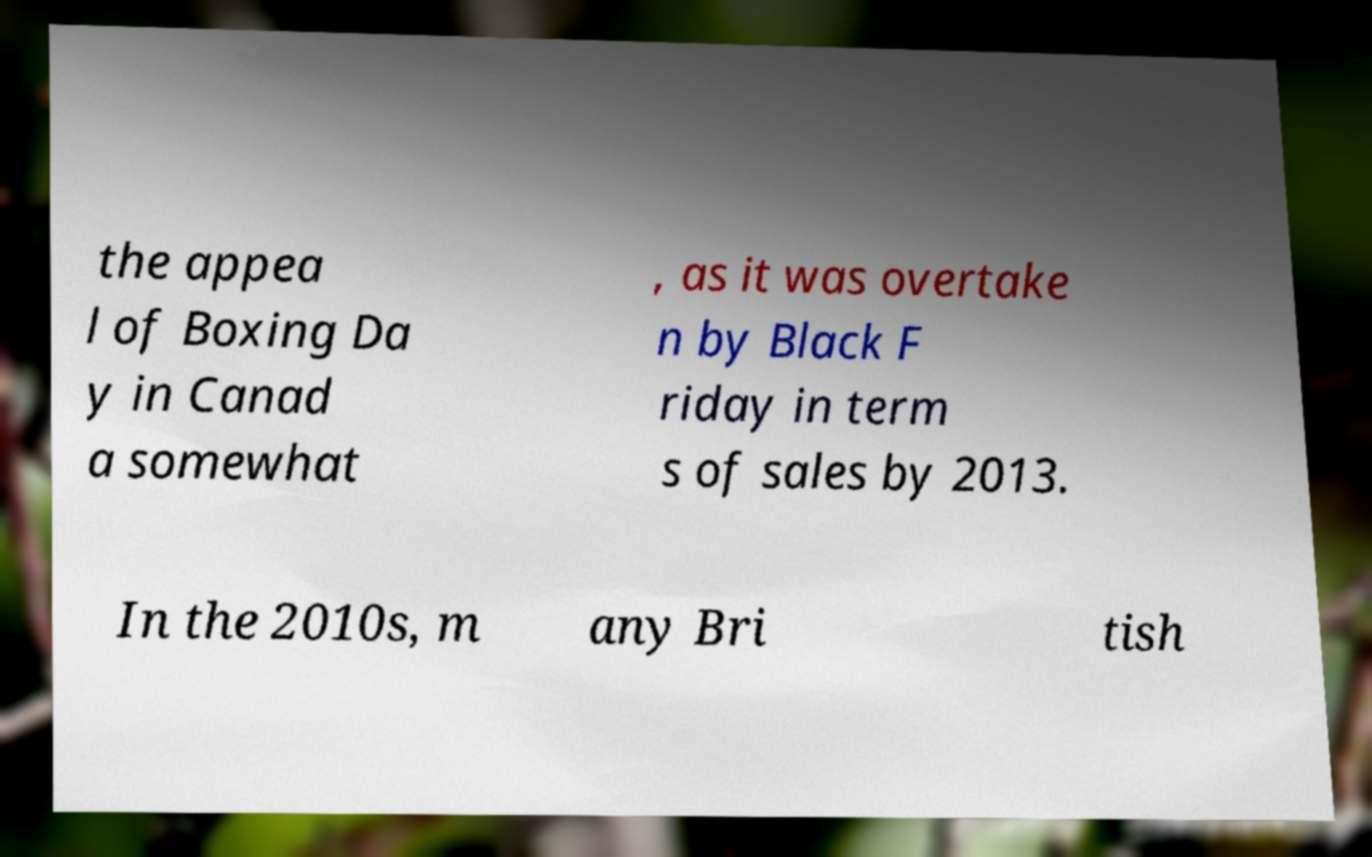I need the written content from this picture converted into text. Can you do that? the appea l of Boxing Da y in Canad a somewhat , as it was overtake n by Black F riday in term s of sales by 2013. In the 2010s, m any Bri tish 